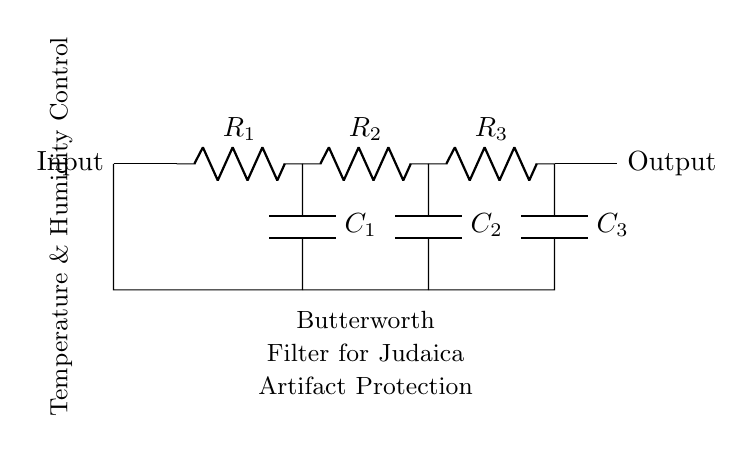What is the first component in the filter circuit? The first component in the circuit is a resistor labeled R1, which is connected to the input.
Answer: R1 How many capacitors are there in the circuit? The circuit includes three capacitors labeled C1, C2, and C3, each connected in parallel with their respective resistors.
Answer: Three What is the purpose of this circuit? The circuit is designed as a Butterworth filter aimed at smoothing out fluctuations in temperature and humidity for protecting Judaica artifacts.
Answer: Smoothing fluctuations Which type of filter is represented in this diagram? The diagram is of a Butterworth filter type, known for its flat frequency response in the passband.
Answer: Butterworth filter What is the configuration of the resistors in this circuit? The resistors are configured in series, where each resistor is connected to a corresponding capacitor to form a low-pass filter arrangement.
Answer: Series configuration How does this filter affect temperature and humidity control? The filter allows low-frequency signals (representing stable temperatures and humidity) to pass while attenuating high-frequency fluctuations that may damage artifacts.
Answer: Attenuates fluctuations What would happen if one capacitor was removed? Removing one capacitor would change the cutoff frequency of the filter, potentially allowing more unwanted high-frequency_noise through, compromising artifact protection.
Answer: Changes cutoff frequency 